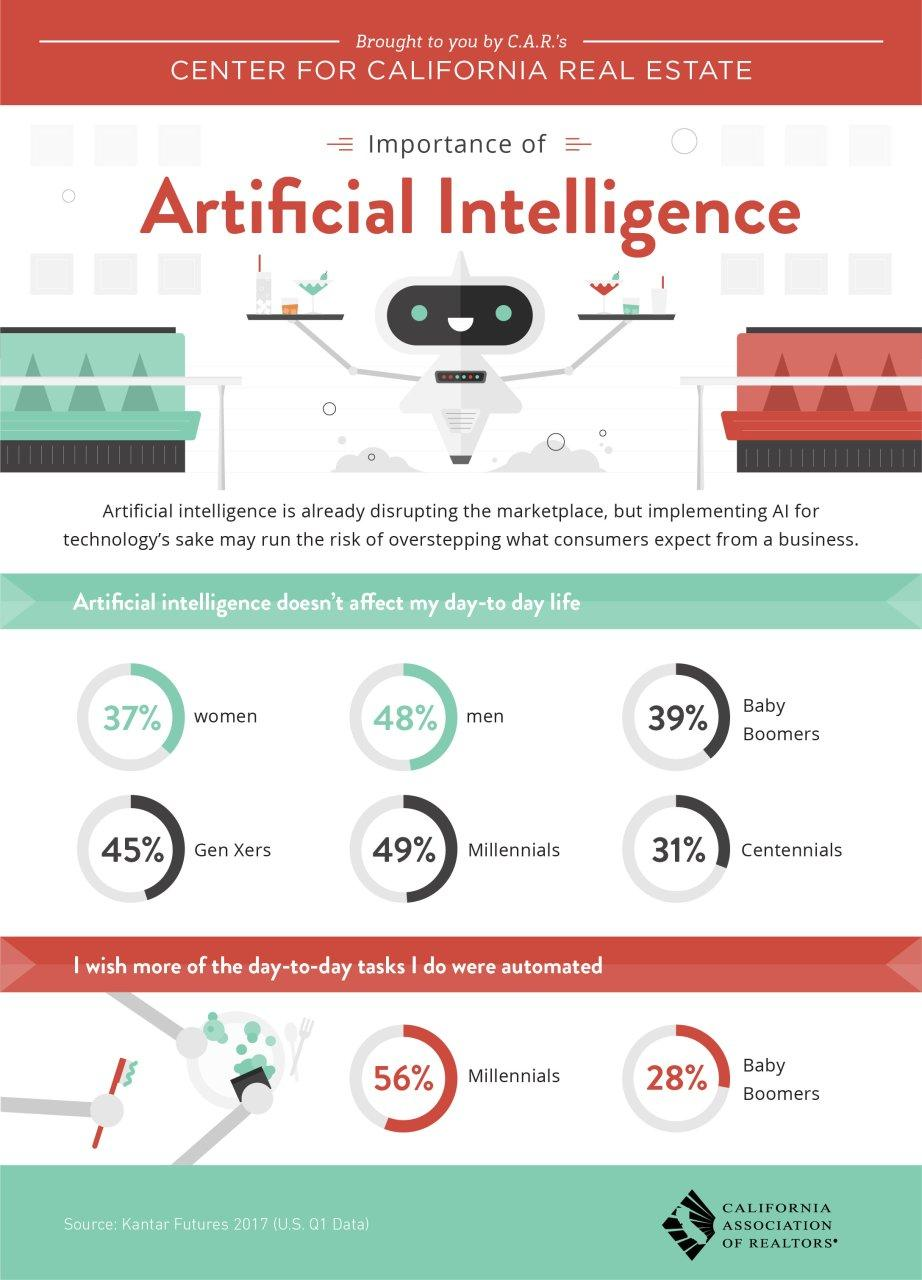Point out several critical features in this image. According to a recent survey, 56% of millennials desire that more of their daily tasks be automated. According to a recent survey, 72% of baby boomers do not want their daily tasks to be automated. According to a recent survey, 49% of millennials believe that their daily life is not significantly impacted by artificial intelligence. According to a recent survey, 69% of centennials believe that their daily life is not significantly influenced by AI. A new survey has revealed that only 44% of millennials do not want their daily tasks to be automated. 